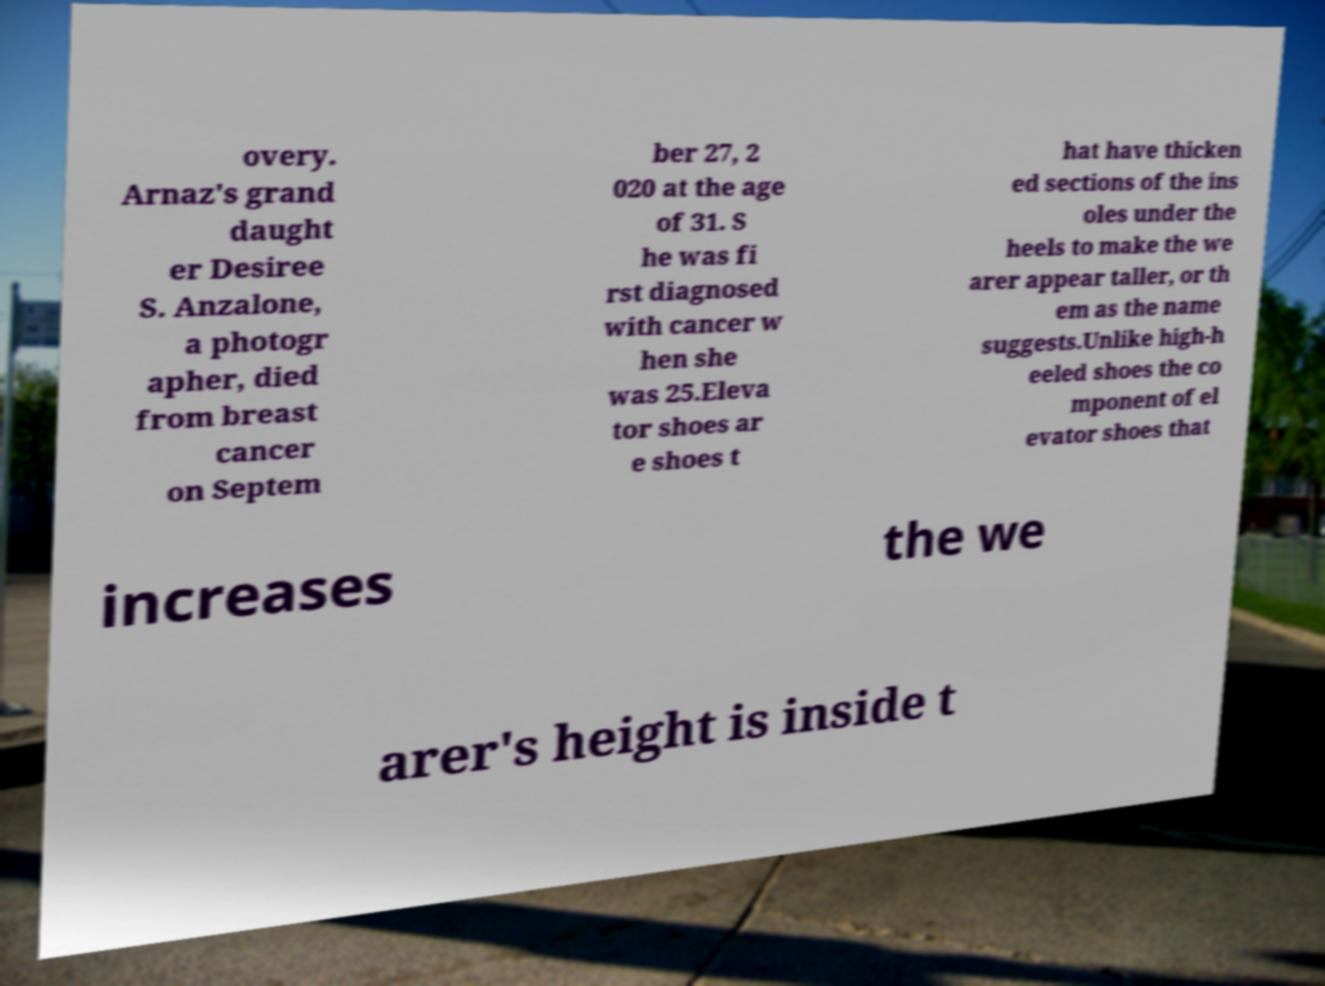Please read and relay the text visible in this image. What does it say? overy. Arnaz's grand daught er Desiree S. Anzalone, a photogr apher, died from breast cancer on Septem ber 27, 2 020 at the age of 31. S he was fi rst diagnosed with cancer w hen she was 25.Eleva tor shoes ar e shoes t hat have thicken ed sections of the ins oles under the heels to make the we arer appear taller, or th em as the name suggests.Unlike high-h eeled shoes the co mponent of el evator shoes that increases the we arer's height is inside t 